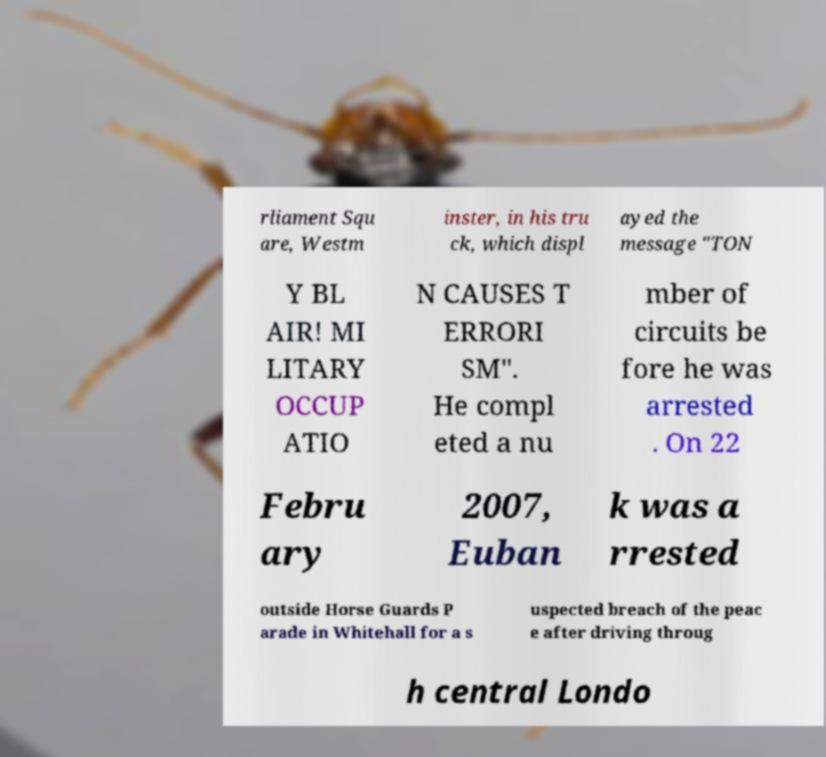Could you assist in decoding the text presented in this image and type it out clearly? rliament Squ are, Westm inster, in his tru ck, which displ ayed the message "TON Y BL AIR! MI LITARY OCCUP ATIO N CAUSES T ERRORI SM". He compl eted a nu mber of circuits be fore he was arrested . On 22 Febru ary 2007, Euban k was a rrested outside Horse Guards P arade in Whitehall for a s uspected breach of the peac e after driving throug h central Londo 